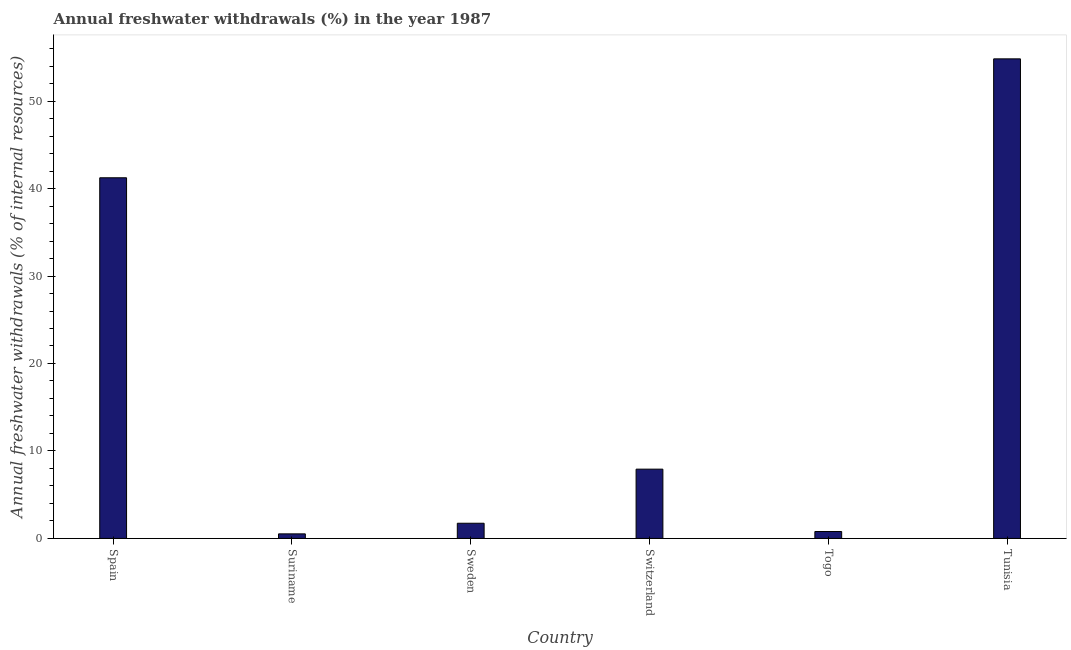What is the title of the graph?
Provide a short and direct response. Annual freshwater withdrawals (%) in the year 1987. What is the label or title of the X-axis?
Your response must be concise. Country. What is the label or title of the Y-axis?
Your response must be concise. Annual freshwater withdrawals (% of internal resources). What is the annual freshwater withdrawals in Suriname?
Keep it short and to the point. 0.52. Across all countries, what is the maximum annual freshwater withdrawals?
Ensure brevity in your answer.  54.83. Across all countries, what is the minimum annual freshwater withdrawals?
Offer a very short reply. 0.52. In which country was the annual freshwater withdrawals maximum?
Your answer should be very brief. Tunisia. In which country was the annual freshwater withdrawals minimum?
Give a very brief answer. Suriname. What is the sum of the annual freshwater withdrawals?
Offer a terse response. 107.03. What is the difference between the annual freshwater withdrawals in Switzerland and Togo?
Offer a terse response. 7.13. What is the average annual freshwater withdrawals per country?
Offer a terse response. 17.84. What is the median annual freshwater withdrawals?
Give a very brief answer. 4.83. In how many countries, is the annual freshwater withdrawals greater than 28 %?
Give a very brief answer. 2. What is the ratio of the annual freshwater withdrawals in Sweden to that in Tunisia?
Make the answer very short. 0.03. Is the difference between the annual freshwater withdrawals in Sweden and Switzerland greater than the difference between any two countries?
Ensure brevity in your answer.  No. What is the difference between the highest and the second highest annual freshwater withdrawals?
Your answer should be compact. 13.6. What is the difference between the highest and the lowest annual freshwater withdrawals?
Provide a succinct answer. 54.3. How many bars are there?
Ensure brevity in your answer.  6. Are all the bars in the graph horizontal?
Offer a terse response. No. How many countries are there in the graph?
Give a very brief answer. 6. What is the Annual freshwater withdrawals (% of internal resources) in Spain?
Provide a succinct answer. 41.23. What is the Annual freshwater withdrawals (% of internal resources) of Suriname?
Keep it short and to the point. 0.52. What is the Annual freshwater withdrawals (% of internal resources) of Sweden?
Your answer should be very brief. 1.74. What is the Annual freshwater withdrawals (% of internal resources) of Switzerland?
Make the answer very short. 7.92. What is the Annual freshwater withdrawals (% of internal resources) of Togo?
Offer a very short reply. 0.79. What is the Annual freshwater withdrawals (% of internal resources) in Tunisia?
Offer a terse response. 54.83. What is the difference between the Annual freshwater withdrawals (% of internal resources) in Spain and Suriname?
Make the answer very short. 40.71. What is the difference between the Annual freshwater withdrawals (% of internal resources) in Spain and Sweden?
Ensure brevity in your answer.  39.5. What is the difference between the Annual freshwater withdrawals (% of internal resources) in Spain and Switzerland?
Give a very brief answer. 33.31. What is the difference between the Annual freshwater withdrawals (% of internal resources) in Spain and Togo?
Provide a short and direct response. 40.44. What is the difference between the Annual freshwater withdrawals (% of internal resources) in Spain and Tunisia?
Provide a short and direct response. -13.6. What is the difference between the Annual freshwater withdrawals (% of internal resources) in Suriname and Sweden?
Offer a terse response. -1.21. What is the difference between the Annual freshwater withdrawals (% of internal resources) in Suriname and Switzerland?
Keep it short and to the point. -7.4. What is the difference between the Annual freshwater withdrawals (% of internal resources) in Suriname and Togo?
Provide a short and direct response. -0.27. What is the difference between the Annual freshwater withdrawals (% of internal resources) in Suriname and Tunisia?
Your answer should be compact. -54.3. What is the difference between the Annual freshwater withdrawals (% of internal resources) in Sweden and Switzerland?
Provide a succinct answer. -6.18. What is the difference between the Annual freshwater withdrawals (% of internal resources) in Sweden and Togo?
Your response must be concise. 0.95. What is the difference between the Annual freshwater withdrawals (% of internal resources) in Sweden and Tunisia?
Provide a succinct answer. -53.09. What is the difference between the Annual freshwater withdrawals (% of internal resources) in Switzerland and Togo?
Your answer should be very brief. 7.13. What is the difference between the Annual freshwater withdrawals (% of internal resources) in Switzerland and Tunisia?
Keep it short and to the point. -46.91. What is the difference between the Annual freshwater withdrawals (% of internal resources) in Togo and Tunisia?
Make the answer very short. -54.04. What is the ratio of the Annual freshwater withdrawals (% of internal resources) in Spain to that in Suriname?
Ensure brevity in your answer.  78.88. What is the ratio of the Annual freshwater withdrawals (% of internal resources) in Spain to that in Sweden?
Provide a succinct answer. 23.74. What is the ratio of the Annual freshwater withdrawals (% of internal resources) in Spain to that in Switzerland?
Keep it short and to the point. 5.21. What is the ratio of the Annual freshwater withdrawals (% of internal resources) in Spain to that in Togo?
Provide a short and direct response. 52.11. What is the ratio of the Annual freshwater withdrawals (% of internal resources) in Spain to that in Tunisia?
Your response must be concise. 0.75. What is the ratio of the Annual freshwater withdrawals (% of internal resources) in Suriname to that in Sweden?
Provide a succinct answer. 0.3. What is the ratio of the Annual freshwater withdrawals (% of internal resources) in Suriname to that in Switzerland?
Your answer should be very brief. 0.07. What is the ratio of the Annual freshwater withdrawals (% of internal resources) in Suriname to that in Togo?
Offer a very short reply. 0.66. What is the ratio of the Annual freshwater withdrawals (% of internal resources) in Suriname to that in Tunisia?
Ensure brevity in your answer.  0.01. What is the ratio of the Annual freshwater withdrawals (% of internal resources) in Sweden to that in Switzerland?
Your response must be concise. 0.22. What is the ratio of the Annual freshwater withdrawals (% of internal resources) in Sweden to that in Togo?
Your answer should be compact. 2.19. What is the ratio of the Annual freshwater withdrawals (% of internal resources) in Sweden to that in Tunisia?
Your answer should be compact. 0.03. What is the ratio of the Annual freshwater withdrawals (% of internal resources) in Switzerland to that in Togo?
Provide a short and direct response. 10.01. What is the ratio of the Annual freshwater withdrawals (% of internal resources) in Switzerland to that in Tunisia?
Your answer should be compact. 0.14. What is the ratio of the Annual freshwater withdrawals (% of internal resources) in Togo to that in Tunisia?
Ensure brevity in your answer.  0.01. 